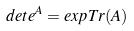<formula> <loc_0><loc_0><loc_500><loc_500>d e t e ^ { A } = e x p T r ( A )</formula> 